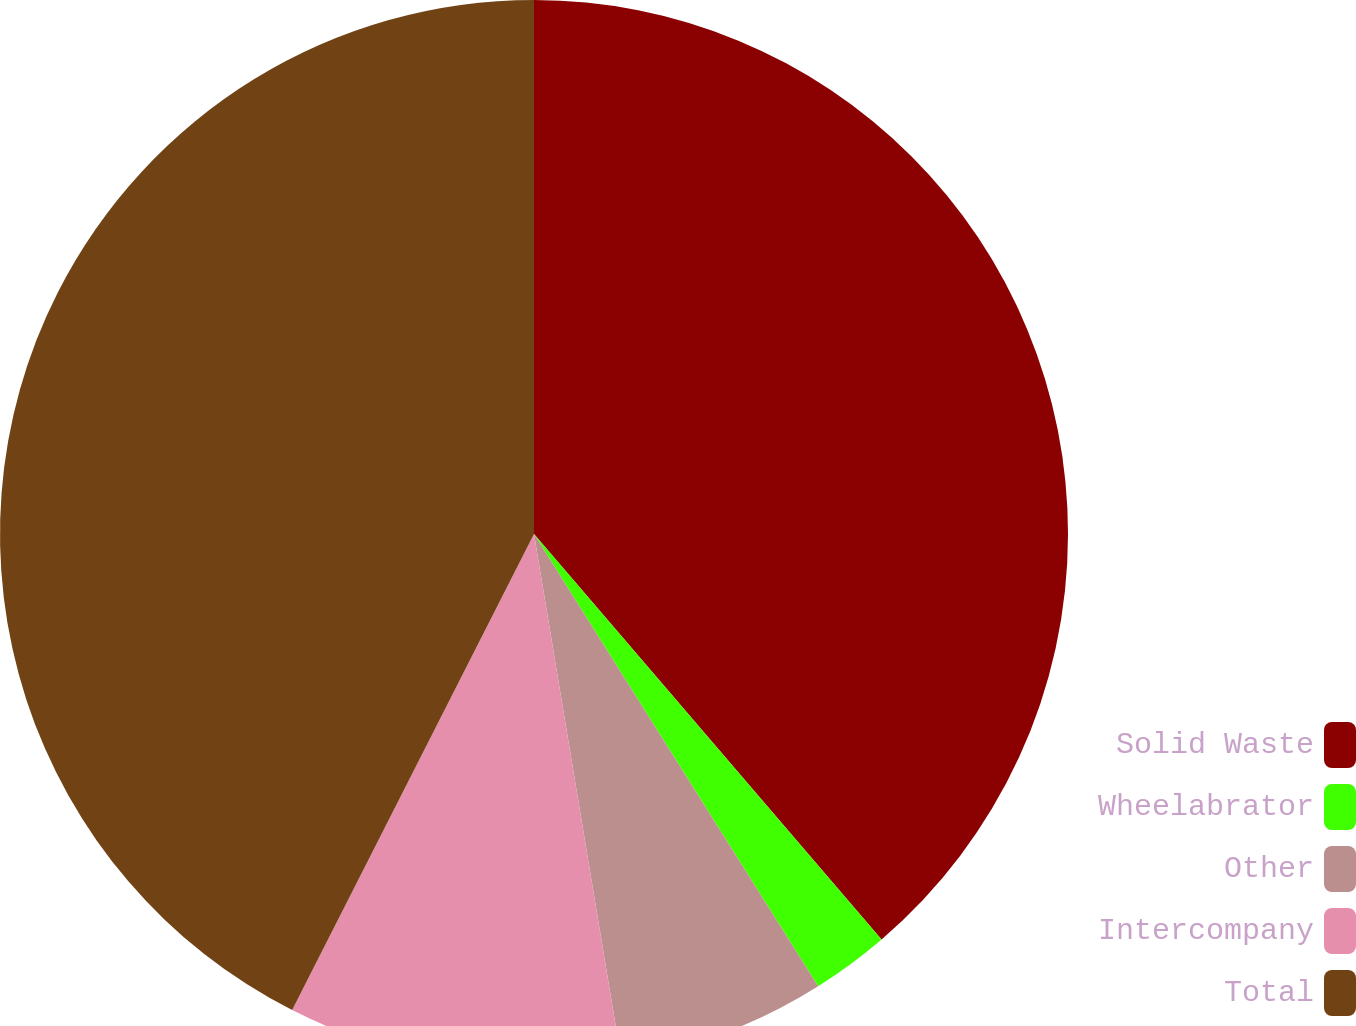Convert chart. <chart><loc_0><loc_0><loc_500><loc_500><pie_chart><fcel>Solid Waste<fcel>Wheelabrator<fcel>Other<fcel>Intercompany<fcel>Total<nl><fcel>38.72%<fcel>2.35%<fcel>6.31%<fcel>10.1%<fcel>42.52%<nl></chart> 